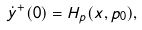<formula> <loc_0><loc_0><loc_500><loc_500>\dot { y } ^ { + } ( 0 ) = H _ { p } ( x , p _ { 0 } ) ,</formula> 